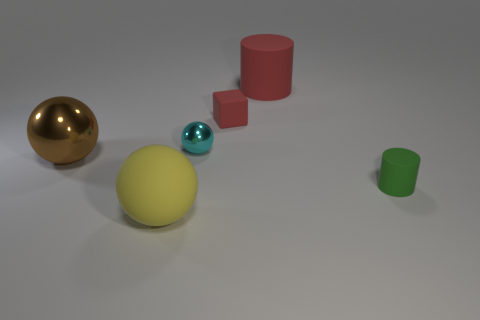Are there any brown things that have the same material as the large yellow sphere?
Provide a short and direct response. No. The sphere that is on the right side of the ball in front of the matte thing that is on the right side of the large red matte object is what color?
Your response must be concise. Cyan. Is the thing that is on the left side of the large yellow ball made of the same material as the small object in front of the cyan sphere?
Ensure brevity in your answer.  No. There is a tiny matte thing to the right of the tiny cube; what shape is it?
Your answer should be compact. Cylinder. How many things are cyan metallic spheres or large objects in front of the brown shiny thing?
Provide a succinct answer. 2. Do the large cylinder and the block have the same material?
Provide a succinct answer. Yes. Is the number of large rubber cylinders in front of the cyan metal object the same as the number of large brown metal spheres behind the brown object?
Your answer should be very brief. Yes. There is a green rubber thing; what number of large brown metallic spheres are in front of it?
Offer a terse response. 0. How many things are either brown shiny spheres or tiny rubber cylinders?
Make the answer very short. 2. How many cyan shiny spheres have the same size as the red rubber cylinder?
Your answer should be compact. 0. 